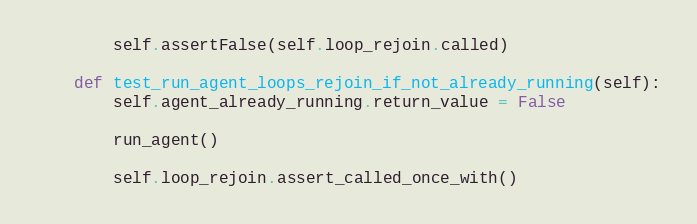<code> <loc_0><loc_0><loc_500><loc_500><_Python_>        self.assertFalse(self.loop_rejoin.called)

    def test_run_agent_loops_rejoin_if_not_already_running(self):
        self.agent_already_running.return_value = False

        run_agent()

        self.loop_rejoin.assert_called_once_with()
</code> 